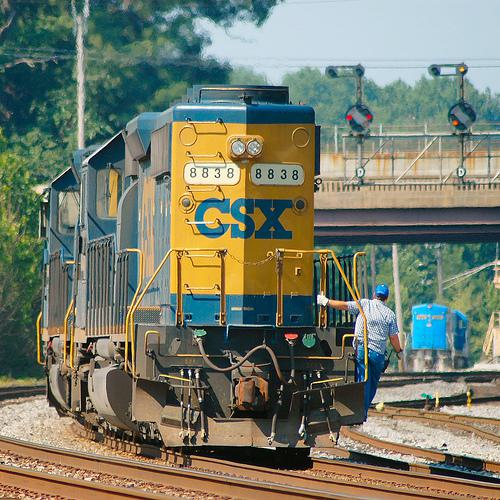What kind of work is the person next to the train likely doing? The person next to the train, dressed in a striped outfit and wearing a protective helmet, appears to be a railroad employee potentially engaged in routine maintenance, inspection, or facilitating the coupling or decoupling of train cars. 